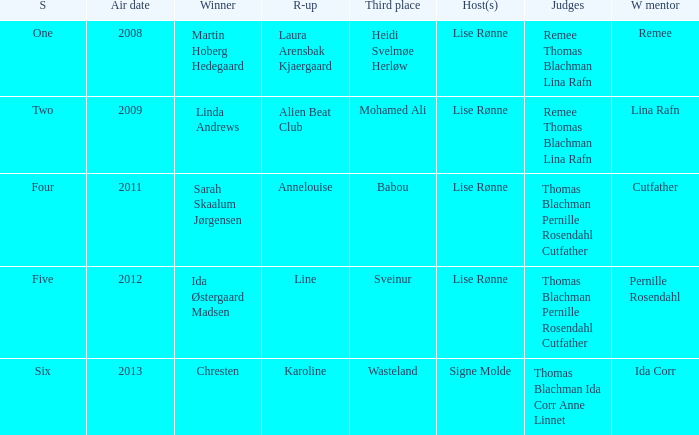Who won third place in season four? Babou. 